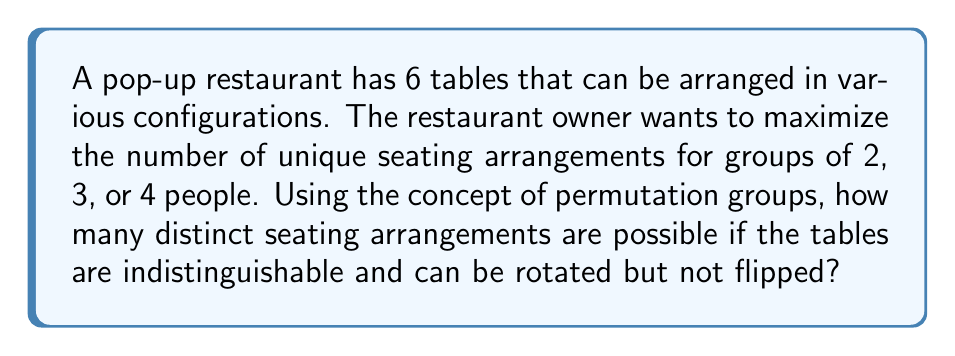What is the answer to this math problem? Let's approach this step-by-step using group theory concepts:

1) First, we need to consider the symmetry group of a regular hexagon, as we have 6 indistinguishable tables that can be rotated.

2) The symmetry group of a regular hexagon without reflections is the cyclic group $C_6$, which has order 6.

3) Now, we need to consider the possible ways to seat groups of 2, 3, or 4 people:
   - For 2 people: $\binom{6}{1} = 6$ ways
   - For 3 people: $\binom{6}{2} = 15$ ways
   - For 4 people: $\binom{6}{2} = 15$ ways

4) The total number of ways to arrange the seating is the sum of these: $6 + 15 + 15 = 36$

5) However, due to the rotational symmetry, some of these arrangements will be equivalent. We need to apply Burnside's lemma to count the number of orbits under the group action.

6) Burnside's lemma states that the number of orbits is:

   $$ |X/G| = \frac{1}{|G|} \sum_{g \in G} |X^g| $$

   where $X$ is the set of all arrangements and $G$ is the symmetry group.

7) In our case:
   - $|G| = 6$ (order of $C_6$)
   - For the identity element: all 36 arrangements are fixed
   - For rotations by 60°, 120°, 180°, 240°, 300°: no arrangements are fixed

8) Applying Burnside's lemma:

   $$ |X/G| = \frac{1}{6} (36 + 0 + 0 + 0 + 0 + 0) = 6 $$

Therefore, there are 6 distinct seating arrangements possible.
Answer: 6 distinct seating arrangements 